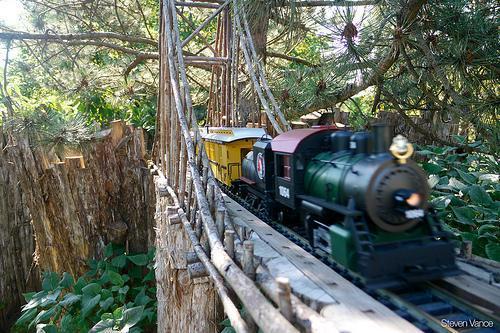How many trains are there?
Give a very brief answer. 1. 